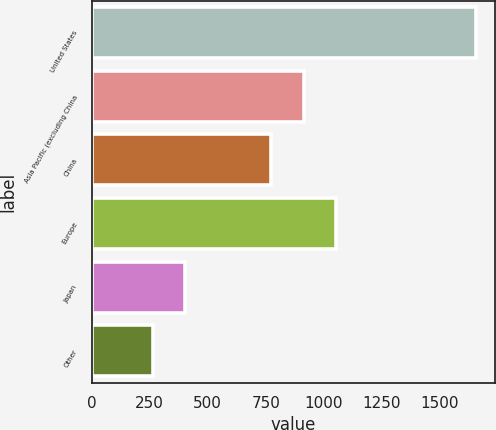Convert chart to OTSL. <chart><loc_0><loc_0><loc_500><loc_500><bar_chart><fcel>United States<fcel>Asia Pacific (excluding China<fcel>China<fcel>Europe<fcel>Japan<fcel>Other<nl><fcel>1657<fcel>914.5<fcel>775<fcel>1054<fcel>401.5<fcel>262<nl></chart> 